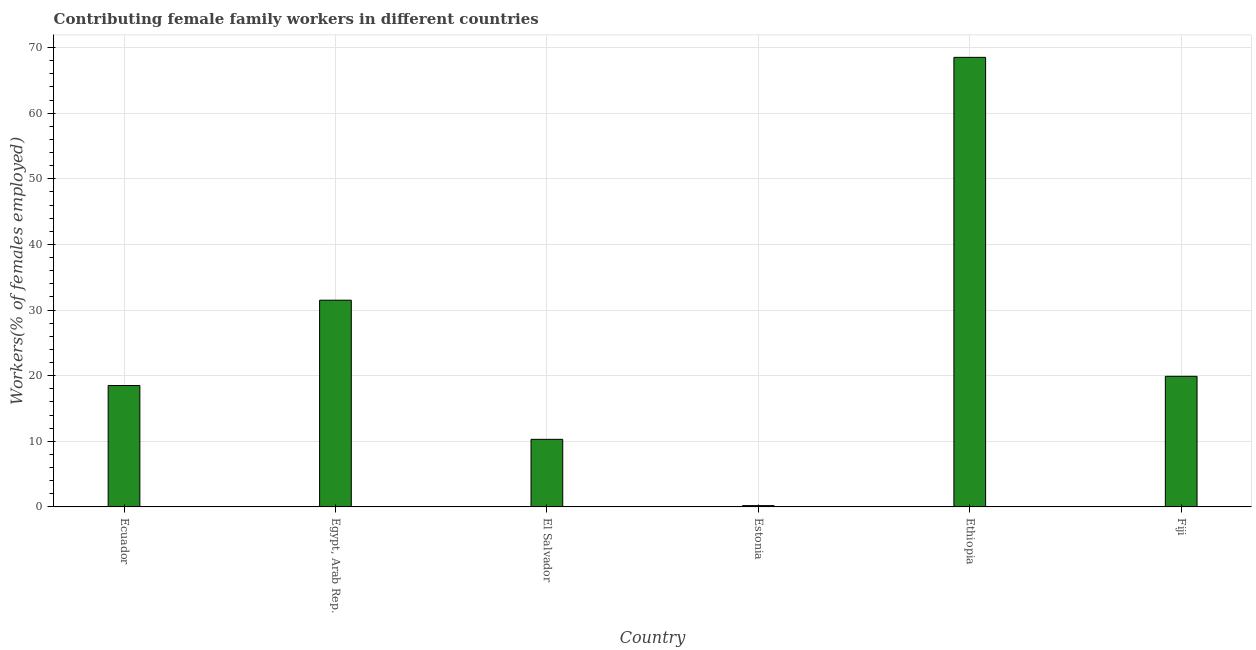Does the graph contain grids?
Provide a short and direct response. Yes. What is the title of the graph?
Keep it short and to the point. Contributing female family workers in different countries. What is the label or title of the X-axis?
Give a very brief answer. Country. What is the label or title of the Y-axis?
Your answer should be very brief. Workers(% of females employed). What is the contributing female family workers in Fiji?
Your answer should be compact. 19.9. Across all countries, what is the maximum contributing female family workers?
Your response must be concise. 68.5. Across all countries, what is the minimum contributing female family workers?
Provide a short and direct response. 0.2. In which country was the contributing female family workers maximum?
Make the answer very short. Ethiopia. In which country was the contributing female family workers minimum?
Ensure brevity in your answer.  Estonia. What is the sum of the contributing female family workers?
Your response must be concise. 148.9. What is the difference between the contributing female family workers in El Salvador and Ethiopia?
Offer a very short reply. -58.2. What is the average contributing female family workers per country?
Make the answer very short. 24.82. What is the median contributing female family workers?
Ensure brevity in your answer.  19.2. In how many countries, is the contributing female family workers greater than 14 %?
Provide a succinct answer. 4. What is the ratio of the contributing female family workers in Ethiopia to that in Fiji?
Provide a succinct answer. 3.44. Is the difference between the contributing female family workers in Ecuador and El Salvador greater than the difference between any two countries?
Provide a short and direct response. No. Is the sum of the contributing female family workers in Egypt, Arab Rep. and El Salvador greater than the maximum contributing female family workers across all countries?
Give a very brief answer. No. What is the difference between the highest and the lowest contributing female family workers?
Provide a short and direct response. 68.3. In how many countries, is the contributing female family workers greater than the average contributing female family workers taken over all countries?
Your answer should be very brief. 2. Are all the bars in the graph horizontal?
Keep it short and to the point. No. How many countries are there in the graph?
Offer a terse response. 6. What is the difference between two consecutive major ticks on the Y-axis?
Provide a succinct answer. 10. What is the Workers(% of females employed) of Egypt, Arab Rep.?
Offer a very short reply. 31.5. What is the Workers(% of females employed) of El Salvador?
Provide a succinct answer. 10.3. What is the Workers(% of females employed) of Estonia?
Give a very brief answer. 0.2. What is the Workers(% of females employed) in Ethiopia?
Your answer should be compact. 68.5. What is the Workers(% of females employed) of Fiji?
Ensure brevity in your answer.  19.9. What is the difference between the Workers(% of females employed) in Ecuador and Egypt, Arab Rep.?
Provide a succinct answer. -13. What is the difference between the Workers(% of females employed) in Ecuador and El Salvador?
Your answer should be compact. 8.2. What is the difference between the Workers(% of females employed) in Ecuador and Estonia?
Give a very brief answer. 18.3. What is the difference between the Workers(% of females employed) in Ecuador and Ethiopia?
Your response must be concise. -50. What is the difference between the Workers(% of females employed) in Ecuador and Fiji?
Your response must be concise. -1.4. What is the difference between the Workers(% of females employed) in Egypt, Arab Rep. and El Salvador?
Your answer should be compact. 21.2. What is the difference between the Workers(% of females employed) in Egypt, Arab Rep. and Estonia?
Your response must be concise. 31.3. What is the difference between the Workers(% of females employed) in Egypt, Arab Rep. and Ethiopia?
Provide a short and direct response. -37. What is the difference between the Workers(% of females employed) in El Salvador and Estonia?
Offer a terse response. 10.1. What is the difference between the Workers(% of females employed) in El Salvador and Ethiopia?
Your response must be concise. -58.2. What is the difference between the Workers(% of females employed) in Estonia and Ethiopia?
Offer a terse response. -68.3. What is the difference between the Workers(% of females employed) in Estonia and Fiji?
Make the answer very short. -19.7. What is the difference between the Workers(% of females employed) in Ethiopia and Fiji?
Provide a short and direct response. 48.6. What is the ratio of the Workers(% of females employed) in Ecuador to that in Egypt, Arab Rep.?
Your response must be concise. 0.59. What is the ratio of the Workers(% of females employed) in Ecuador to that in El Salvador?
Offer a terse response. 1.8. What is the ratio of the Workers(% of females employed) in Ecuador to that in Estonia?
Provide a short and direct response. 92.5. What is the ratio of the Workers(% of females employed) in Ecuador to that in Ethiopia?
Make the answer very short. 0.27. What is the ratio of the Workers(% of females employed) in Ecuador to that in Fiji?
Offer a very short reply. 0.93. What is the ratio of the Workers(% of females employed) in Egypt, Arab Rep. to that in El Salvador?
Provide a short and direct response. 3.06. What is the ratio of the Workers(% of females employed) in Egypt, Arab Rep. to that in Estonia?
Offer a very short reply. 157.5. What is the ratio of the Workers(% of females employed) in Egypt, Arab Rep. to that in Ethiopia?
Keep it short and to the point. 0.46. What is the ratio of the Workers(% of females employed) in Egypt, Arab Rep. to that in Fiji?
Provide a succinct answer. 1.58. What is the ratio of the Workers(% of females employed) in El Salvador to that in Estonia?
Provide a short and direct response. 51.5. What is the ratio of the Workers(% of females employed) in El Salvador to that in Ethiopia?
Make the answer very short. 0.15. What is the ratio of the Workers(% of females employed) in El Salvador to that in Fiji?
Ensure brevity in your answer.  0.52. What is the ratio of the Workers(% of females employed) in Estonia to that in Ethiopia?
Make the answer very short. 0. What is the ratio of the Workers(% of females employed) in Ethiopia to that in Fiji?
Your answer should be very brief. 3.44. 